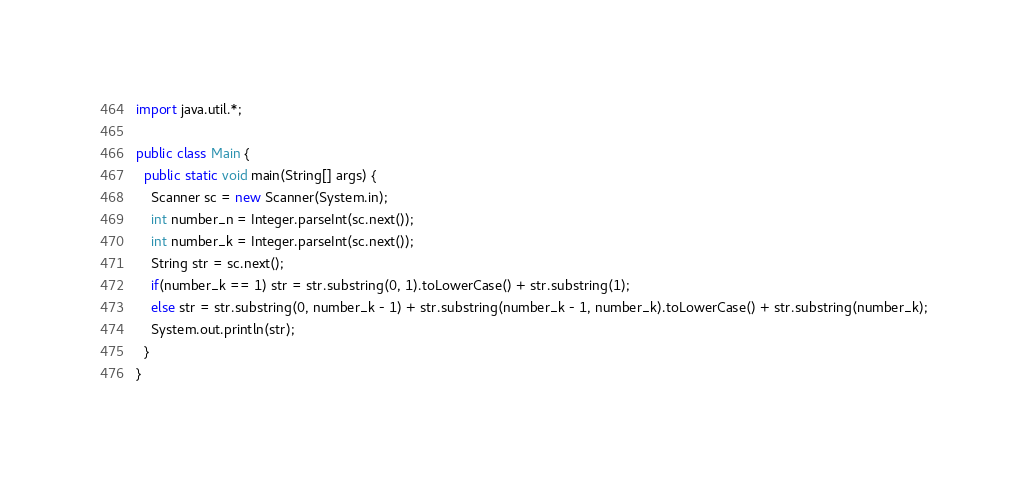Convert code to text. <code><loc_0><loc_0><loc_500><loc_500><_Java_>import java.util.*;

public class Main {
  public static void main(String[] args) {
    Scanner sc = new Scanner(System.in);
    int number_n = Integer.parseInt(sc.next());
    int number_k = Integer.parseInt(sc.next());
    String str = sc.next();
    if(number_k == 1) str = str.substring(0, 1).toLowerCase() + str.substring(1);
    else str = str.substring(0, number_k - 1) + str.substring(number_k - 1, number_k).toLowerCase() + str.substring(number_k);
    System.out.println(str);
  }
}
</code> 